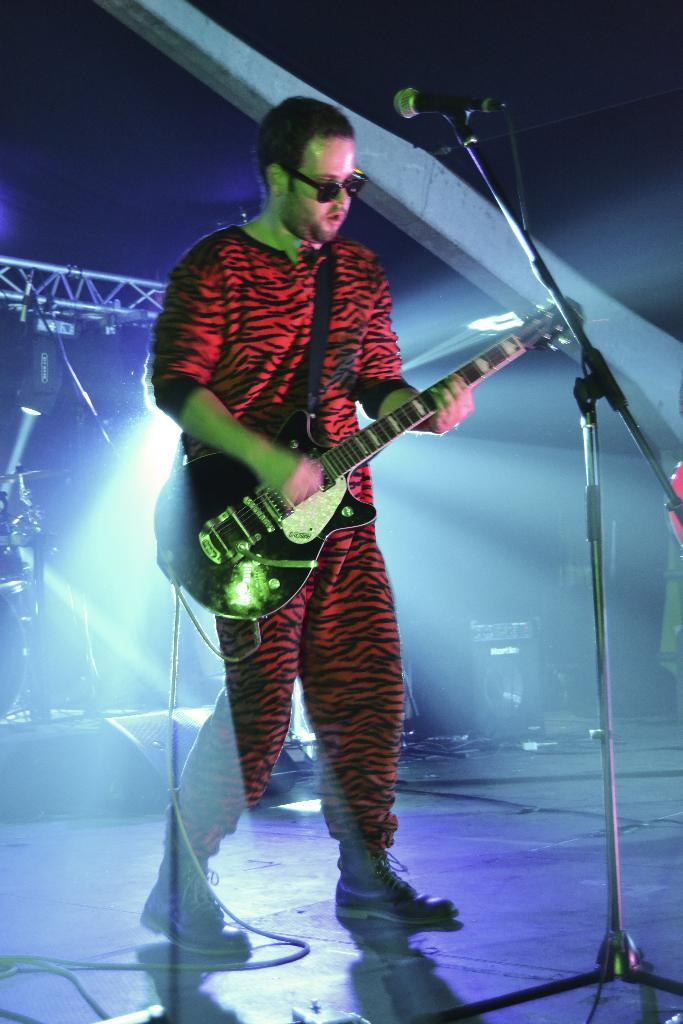Who is the main subject in the image? There is a man in the center of the image. What is the man holding in the image? The man is holding a guitar. What object is in front of the man? There is a microphone in front of the man. What can be seen in the background of the image? There are musical instruments visible in the background. What color is the crayon the man is using to draw on the wall in the image? There is no crayon or drawing on the wall in the image; the man is holding a guitar and standing near a microphone. 